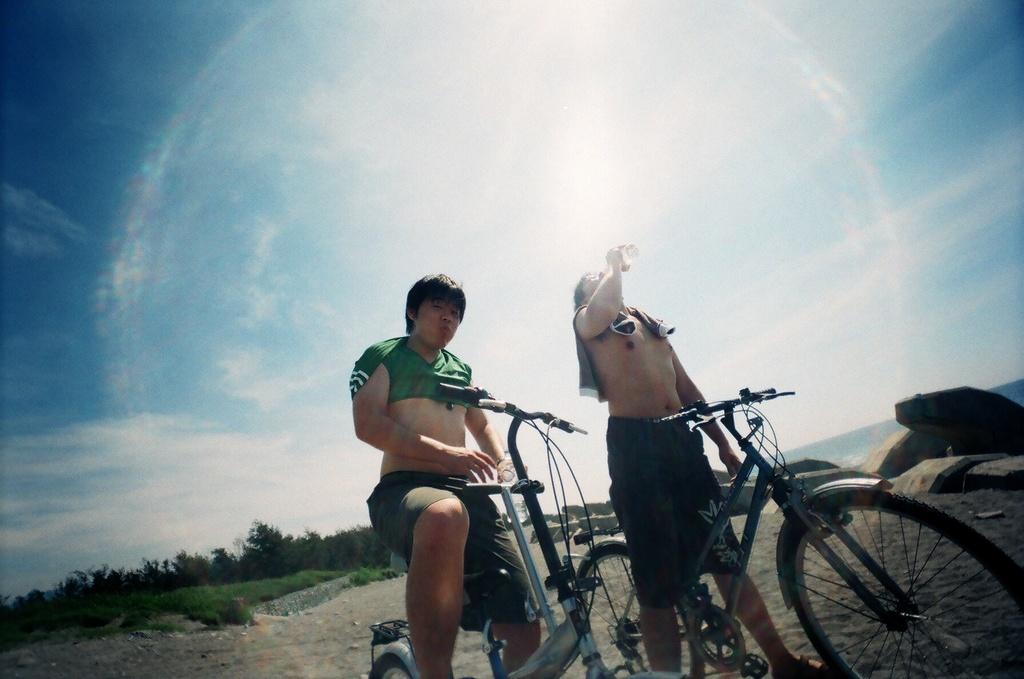How many people are in the image? There are two persons in the image. What are the people doing in the image? One person is drinking from a bottle, and the other person is likely riding a cycle. What can be seen in the background of the image? There are trees and sky visible in the background of the image. What is the condition of the sky in the image? The sky has clouds in it. What other objects are present in the image? There are cycles and rocks in the image. What type of list can be seen in the image? There is no list present in the image. How does the trail look like in the image? There is no trail visible in the image. 